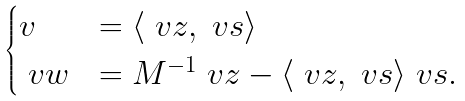<formula> <loc_0><loc_0><loc_500><loc_500>\begin{cases} v & = \langle \ v z , \ v s \rangle \\ \ v w & = M ^ { - 1 } \ v z - \langle \ v z , \ v s \rangle \ v s . \end{cases}</formula> 